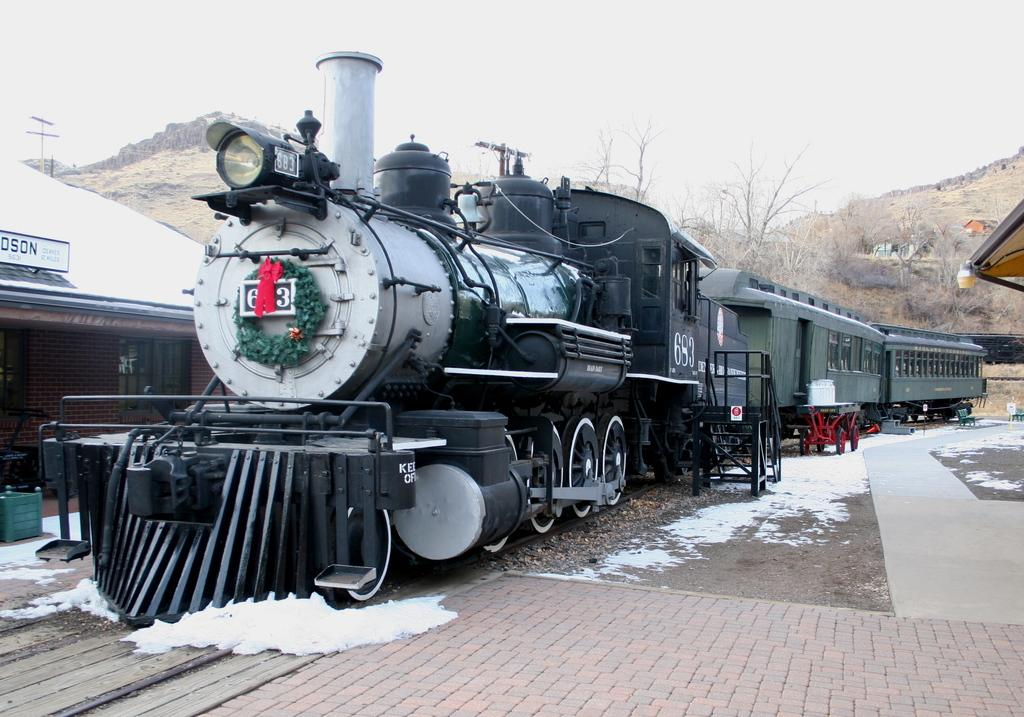What is the main subject of the image? The main subject of the image is a train. Where is the train located in the image? The train is on a railway track. What can be seen in the background of the image? There is a house, a mountain, trees, and the sky visible in the background of the image. What is the condition of the ground in the image? The ground has snow on it. What type of credit card is being used to purchase a property in the image? There is no credit card or property purchase depicted in the image; it features a train on a railway track with a snowy background. 